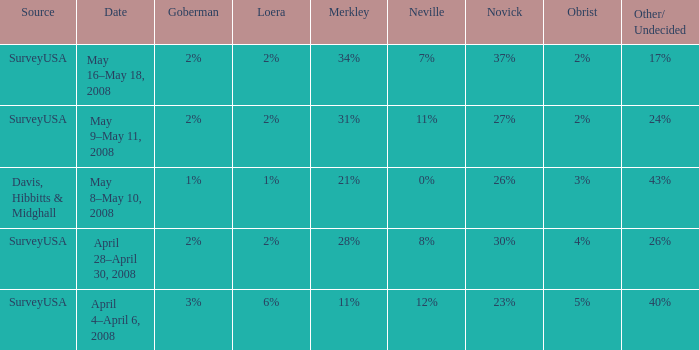Which Goberman has an Obrist of 2%, and a Merkley of 34%? 2%. 